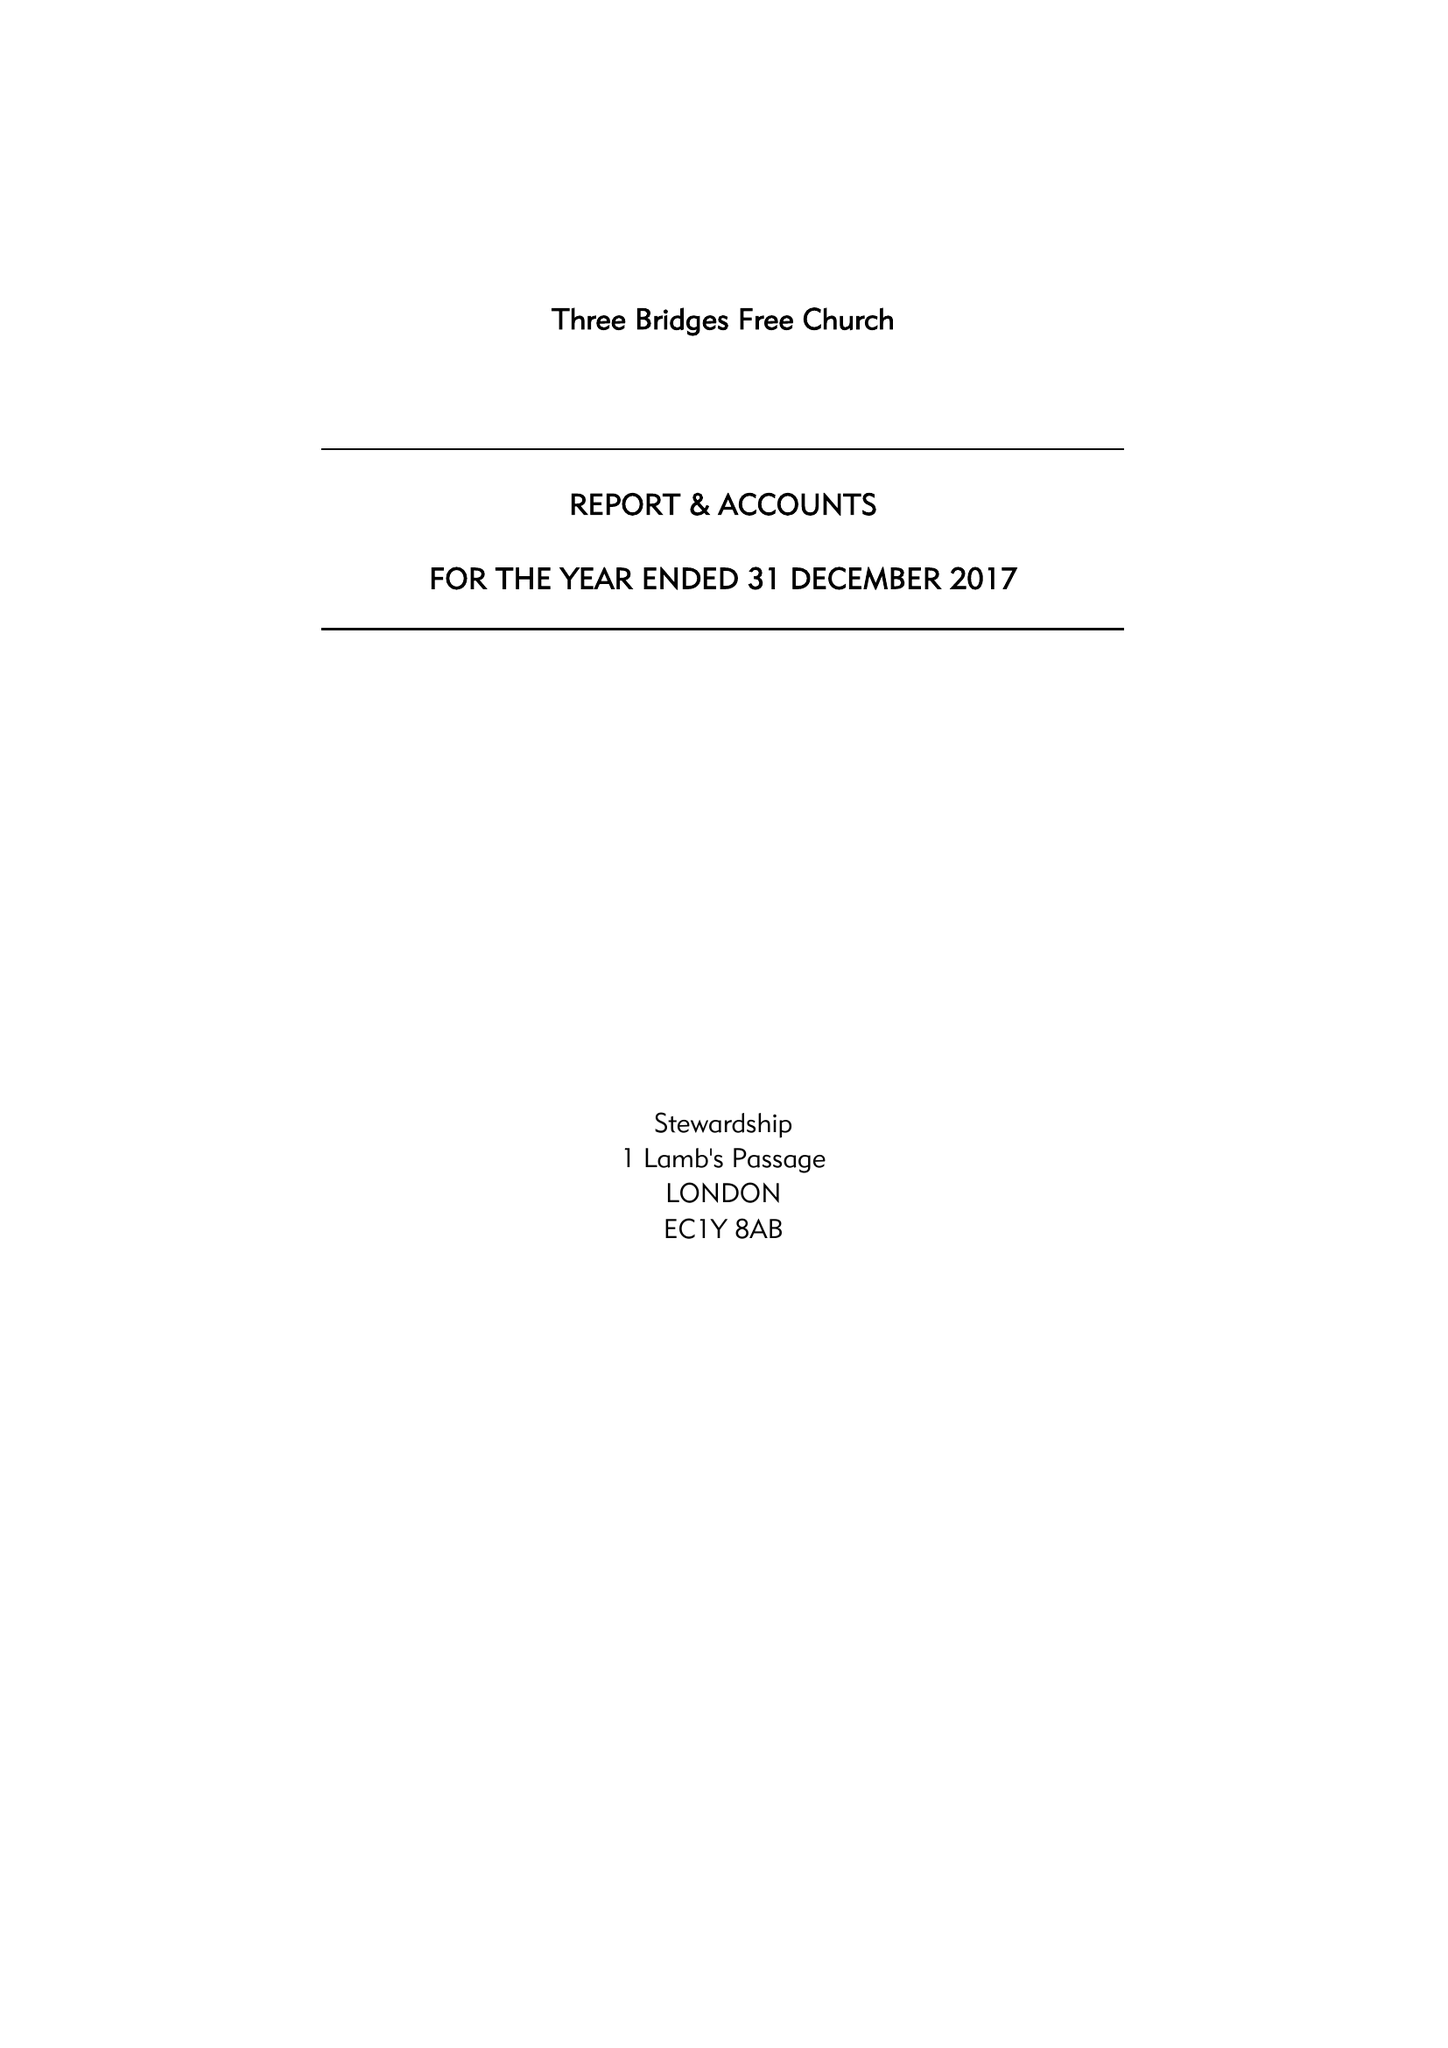What is the value for the address__post_town?
Answer the question using a single word or phrase. CRAWLEY 